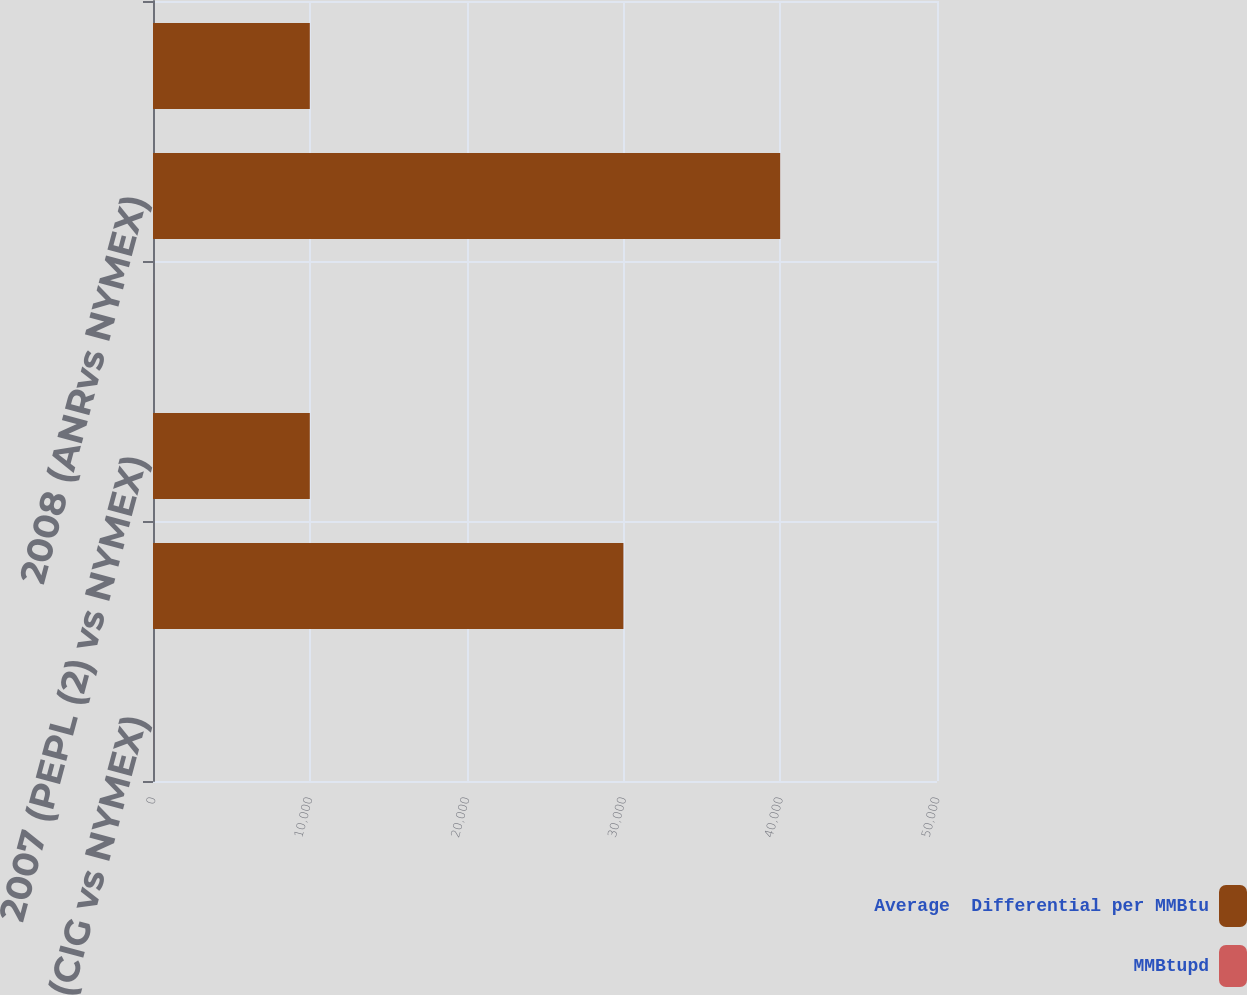Convert chart to OTSL. <chart><loc_0><loc_0><loc_500><loc_500><stacked_bar_chart><ecel><fcel>2007 (CIG vs NYMEX)<fcel>2007 (ANR (1) vs NYMEX)<fcel>2007 (PEPL (2) vs NYMEX)<fcel>2008 (CIG vs NYMEX)<fcel>2008 (ANRvs NYMEX)<fcel>2008 (PEPL vs NYMEX)<nl><fcel>Average  Differential per MMBtu<fcel>1.84<fcel>30000<fcel>10000<fcel>1.84<fcel>40000<fcel>10000<nl><fcel>MMBtupd<fcel>2.02<fcel>1.17<fcel>1.11<fcel>1.66<fcel>1.01<fcel>0.98<nl></chart> 